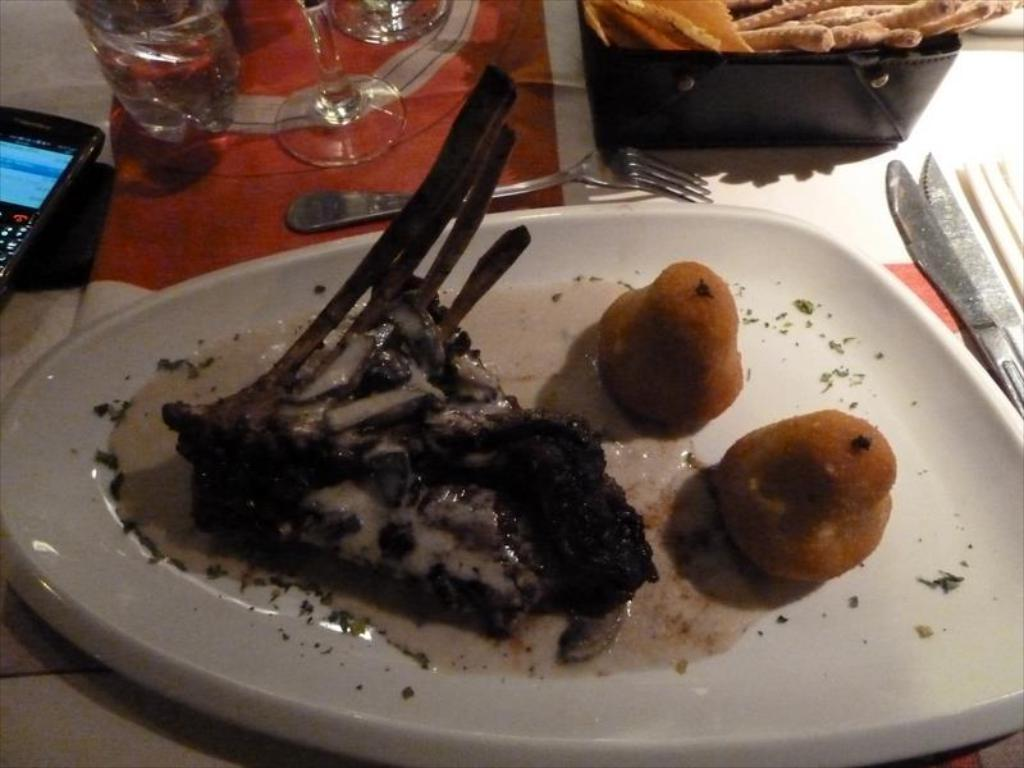What is the food item placed on the plate in the image? The facts do not specify the type of food item on the plate. What utensils are present on the table in the image? There are spoons on the table in the image. What type of tableware is present on the table in the image? There are glasses on the table in the image. What type of map is visible on the table in the image? There is no map present in the image; the facts mention only a food item on a plate, spoons, and glasses on the table. 